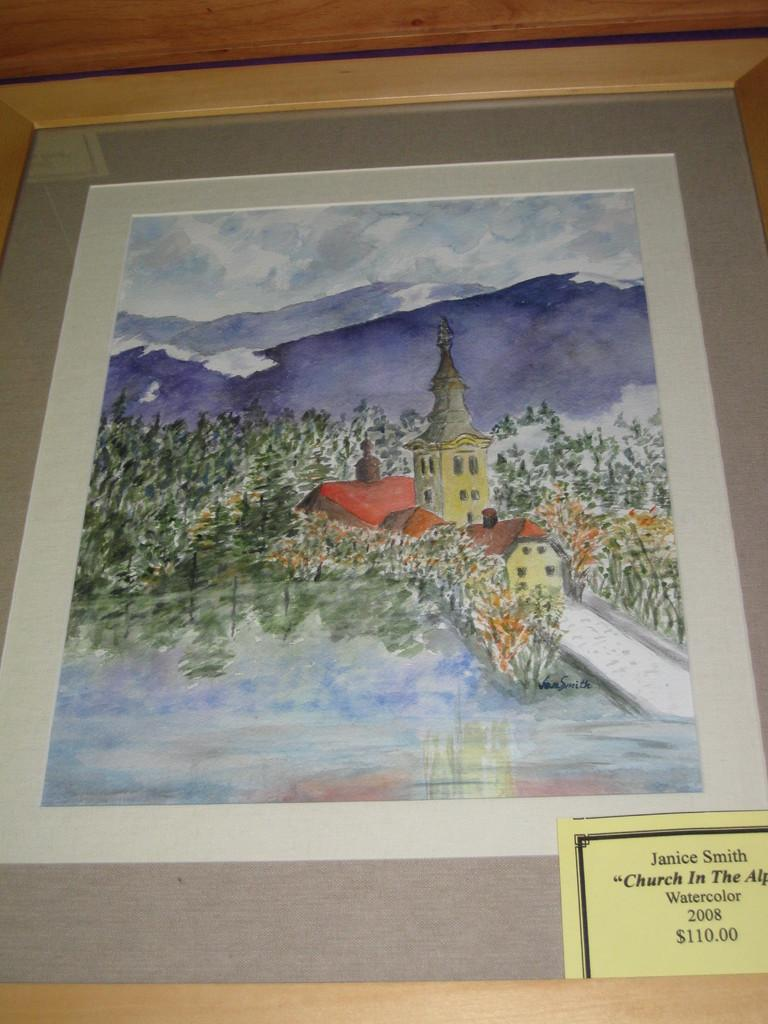<image>
Present a compact description of the photo's key features. A watercolor painting of a church is being sold 